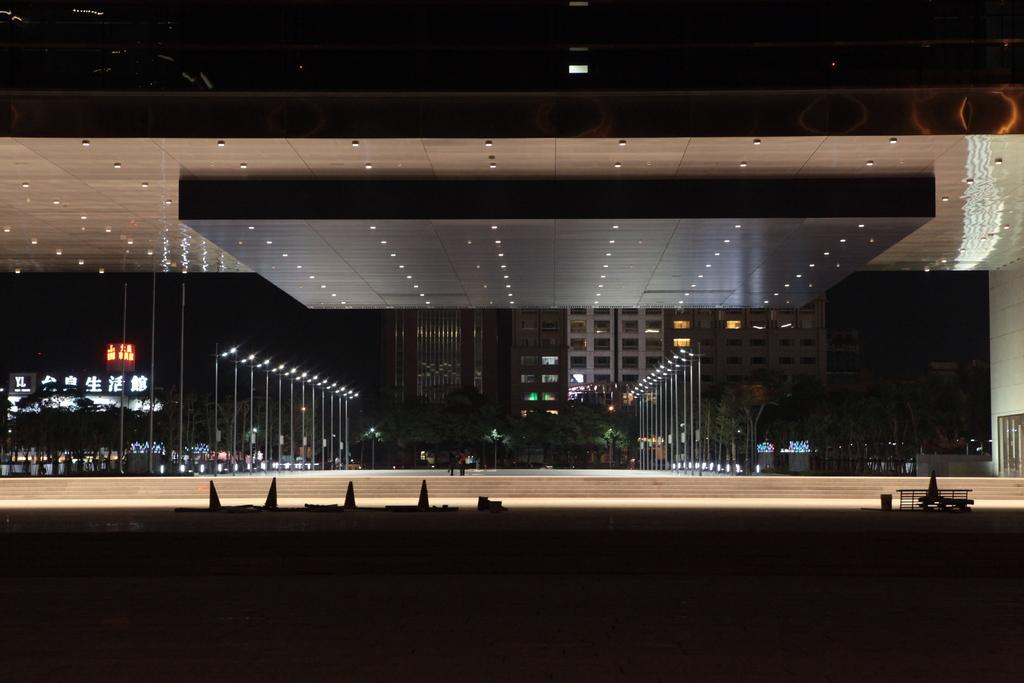What type of structure can be seen in the image? There is a building in the image. Can you describe the position of the second building in relation to the first building? There is another building in front of the first building. What type of infrastructure is present in the image? There are street light poles and a traffic signal light in the image. How would you describe the lighting conditions at the bottom of the image? The bottom part of the image has a dark view. What type of bear can be seen interacting with the traffic signal light in the image? There is no bear present in the image; it features buildings, street light poles, and a traffic signal light. How many bees are visible on the street light poles in the image? There are no bees visible on the street light poles in the image. 